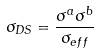<formula> <loc_0><loc_0><loc_500><loc_500>\sigma _ { D S } = \frac { \sigma ^ { a } \sigma ^ { b } } { \sigma _ { e f f } }</formula> 